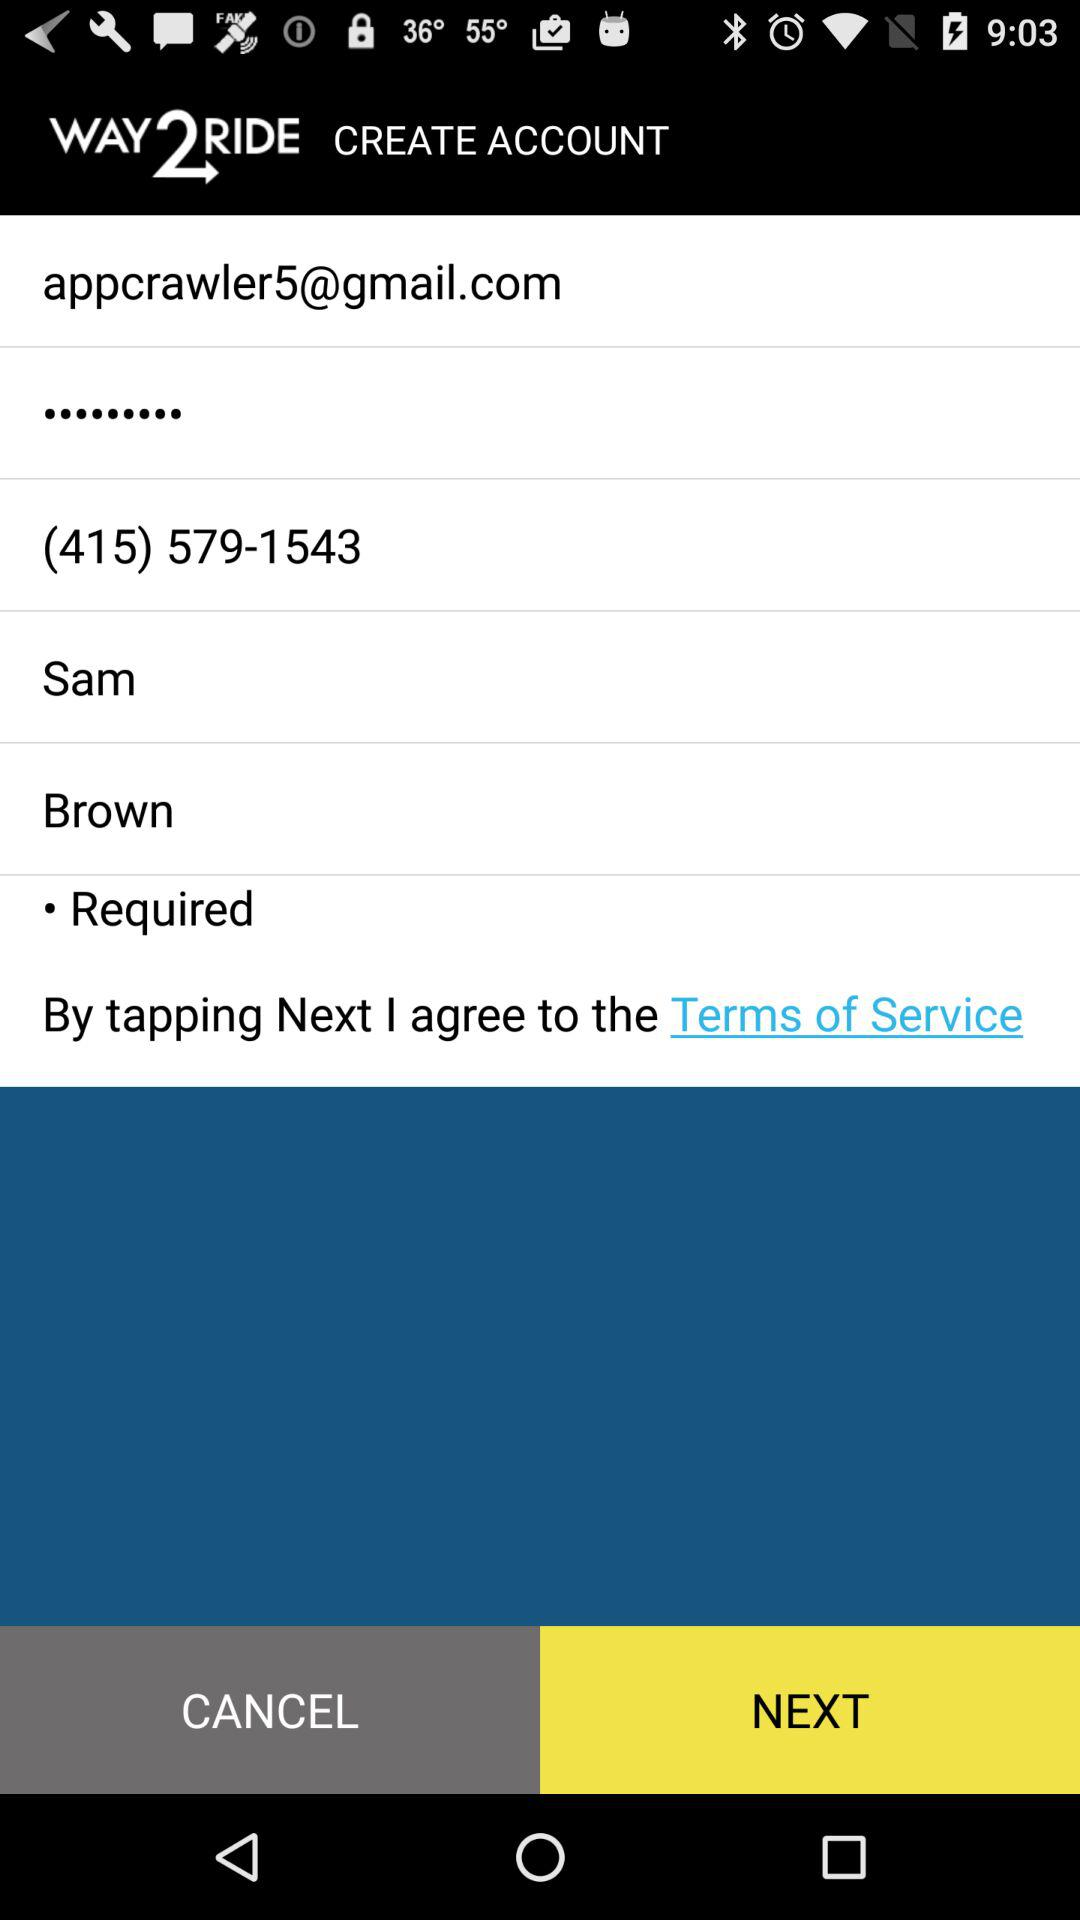What is the given contact number? The given contact number is (415) 579-1543. 